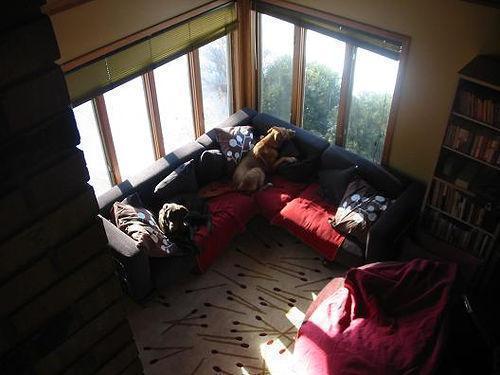What is on the couch?
Answer the question by selecting the correct answer among the 4 following choices.
Options: Cow, dog, llama, old man. Dog. 